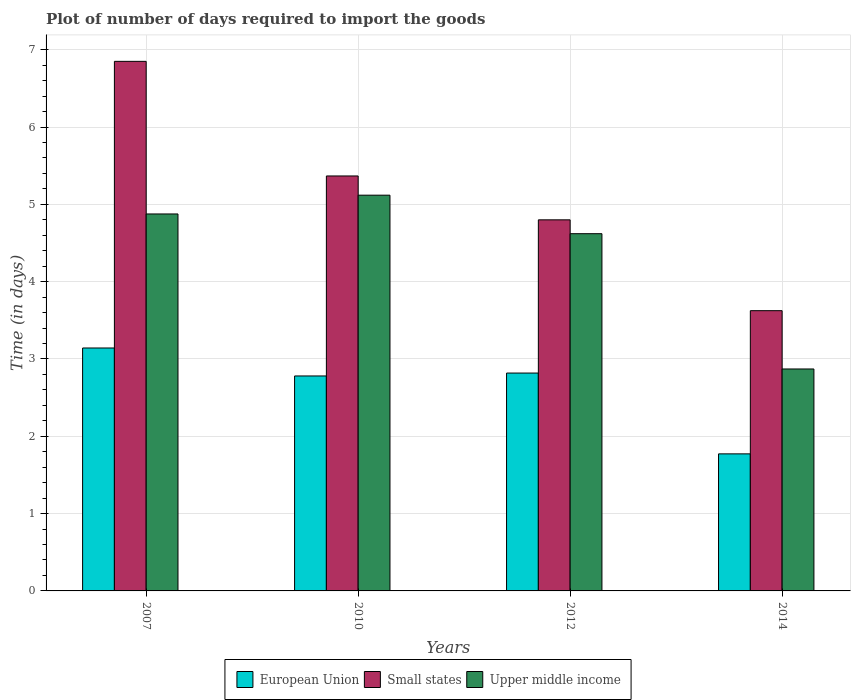How many groups of bars are there?
Make the answer very short. 4. Are the number of bars per tick equal to the number of legend labels?
Provide a short and direct response. Yes. Are the number of bars on each tick of the X-axis equal?
Provide a short and direct response. Yes. How many bars are there on the 1st tick from the left?
Keep it short and to the point. 3. In how many cases, is the number of bars for a given year not equal to the number of legend labels?
Offer a terse response. 0. What is the time required to import goods in Upper middle income in 2014?
Make the answer very short. 2.87. Across all years, what is the maximum time required to import goods in Upper middle income?
Offer a very short reply. 5.12. Across all years, what is the minimum time required to import goods in Small states?
Offer a terse response. 3.62. In which year was the time required to import goods in Small states minimum?
Offer a terse response. 2014. What is the total time required to import goods in Small states in the graph?
Provide a short and direct response. 20.64. What is the difference between the time required to import goods in Small states in 2010 and that in 2014?
Make the answer very short. 1.74. What is the difference between the time required to import goods in Upper middle income in 2007 and the time required to import goods in Small states in 2014?
Offer a terse response. 1.25. What is the average time required to import goods in European Union per year?
Give a very brief answer. 2.63. In the year 2007, what is the difference between the time required to import goods in European Union and time required to import goods in Upper middle income?
Keep it short and to the point. -1.73. In how many years, is the time required to import goods in European Union greater than 4.2 days?
Your answer should be compact. 0. What is the ratio of the time required to import goods in European Union in 2012 to that in 2014?
Ensure brevity in your answer.  1.59. Is the difference between the time required to import goods in European Union in 2007 and 2010 greater than the difference between the time required to import goods in Upper middle income in 2007 and 2010?
Offer a terse response. Yes. What is the difference between the highest and the second highest time required to import goods in European Union?
Give a very brief answer. 0.32. What is the difference between the highest and the lowest time required to import goods in Small states?
Offer a very short reply. 3.22. In how many years, is the time required to import goods in Small states greater than the average time required to import goods in Small states taken over all years?
Give a very brief answer. 2. Is the sum of the time required to import goods in Upper middle income in 2010 and 2014 greater than the maximum time required to import goods in European Union across all years?
Make the answer very short. Yes. What does the 1st bar from the left in 2012 represents?
Offer a very short reply. European Union. What does the 1st bar from the right in 2007 represents?
Give a very brief answer. Upper middle income. Is it the case that in every year, the sum of the time required to import goods in Small states and time required to import goods in Upper middle income is greater than the time required to import goods in European Union?
Give a very brief answer. Yes. How many bars are there?
Your response must be concise. 12. Are all the bars in the graph horizontal?
Ensure brevity in your answer.  No. How many years are there in the graph?
Your response must be concise. 4. What is the title of the graph?
Your response must be concise. Plot of number of days required to import the goods. What is the label or title of the Y-axis?
Keep it short and to the point. Time (in days). What is the Time (in days) of European Union in 2007?
Keep it short and to the point. 3.14. What is the Time (in days) in Small states in 2007?
Your answer should be compact. 6.85. What is the Time (in days) of Upper middle income in 2007?
Offer a very short reply. 4.88. What is the Time (in days) of European Union in 2010?
Your answer should be compact. 2.78. What is the Time (in days) of Small states in 2010?
Ensure brevity in your answer.  5.37. What is the Time (in days) of Upper middle income in 2010?
Offer a terse response. 5.12. What is the Time (in days) of European Union in 2012?
Your answer should be compact. 2.82. What is the Time (in days) in Upper middle income in 2012?
Your response must be concise. 4.62. What is the Time (in days) in European Union in 2014?
Make the answer very short. 1.77. What is the Time (in days) of Small states in 2014?
Your answer should be very brief. 3.62. What is the Time (in days) of Upper middle income in 2014?
Provide a succinct answer. 2.87. Across all years, what is the maximum Time (in days) in European Union?
Your answer should be compact. 3.14. Across all years, what is the maximum Time (in days) in Small states?
Ensure brevity in your answer.  6.85. Across all years, what is the maximum Time (in days) in Upper middle income?
Give a very brief answer. 5.12. Across all years, what is the minimum Time (in days) in European Union?
Your response must be concise. 1.77. Across all years, what is the minimum Time (in days) in Small states?
Provide a short and direct response. 3.62. Across all years, what is the minimum Time (in days) of Upper middle income?
Give a very brief answer. 2.87. What is the total Time (in days) in European Union in the graph?
Offer a very short reply. 10.51. What is the total Time (in days) in Small states in the graph?
Your answer should be very brief. 20.64. What is the total Time (in days) of Upper middle income in the graph?
Your answer should be very brief. 17.49. What is the difference between the Time (in days) of European Union in 2007 and that in 2010?
Ensure brevity in your answer.  0.36. What is the difference between the Time (in days) of Small states in 2007 and that in 2010?
Give a very brief answer. 1.48. What is the difference between the Time (in days) of Upper middle income in 2007 and that in 2010?
Offer a terse response. -0.24. What is the difference between the Time (in days) in European Union in 2007 and that in 2012?
Ensure brevity in your answer.  0.32. What is the difference between the Time (in days) of Small states in 2007 and that in 2012?
Your answer should be compact. 2.05. What is the difference between the Time (in days) of Upper middle income in 2007 and that in 2012?
Offer a terse response. 0.26. What is the difference between the Time (in days) of European Union in 2007 and that in 2014?
Your answer should be very brief. 1.37. What is the difference between the Time (in days) of Small states in 2007 and that in 2014?
Your answer should be compact. 3.23. What is the difference between the Time (in days) of Upper middle income in 2007 and that in 2014?
Offer a terse response. 2. What is the difference between the Time (in days) in European Union in 2010 and that in 2012?
Give a very brief answer. -0.04. What is the difference between the Time (in days) of Small states in 2010 and that in 2012?
Give a very brief answer. 0.57. What is the difference between the Time (in days) of Upper middle income in 2010 and that in 2012?
Keep it short and to the point. 0.5. What is the difference between the Time (in days) in European Union in 2010 and that in 2014?
Your answer should be compact. 1.01. What is the difference between the Time (in days) in Small states in 2010 and that in 2014?
Offer a terse response. 1.74. What is the difference between the Time (in days) of Upper middle income in 2010 and that in 2014?
Keep it short and to the point. 2.25. What is the difference between the Time (in days) of European Union in 2012 and that in 2014?
Make the answer very short. 1.05. What is the difference between the Time (in days) in Small states in 2012 and that in 2014?
Offer a very short reply. 1.18. What is the difference between the Time (in days) of Upper middle income in 2012 and that in 2014?
Your answer should be compact. 1.75. What is the difference between the Time (in days) of European Union in 2007 and the Time (in days) of Small states in 2010?
Your answer should be very brief. -2.23. What is the difference between the Time (in days) of European Union in 2007 and the Time (in days) of Upper middle income in 2010?
Give a very brief answer. -1.98. What is the difference between the Time (in days) of Small states in 2007 and the Time (in days) of Upper middle income in 2010?
Ensure brevity in your answer.  1.73. What is the difference between the Time (in days) of European Union in 2007 and the Time (in days) of Small states in 2012?
Provide a succinct answer. -1.66. What is the difference between the Time (in days) of European Union in 2007 and the Time (in days) of Upper middle income in 2012?
Provide a short and direct response. -1.48. What is the difference between the Time (in days) of Small states in 2007 and the Time (in days) of Upper middle income in 2012?
Your answer should be compact. 2.23. What is the difference between the Time (in days) in European Union in 2007 and the Time (in days) in Small states in 2014?
Your answer should be compact. -0.48. What is the difference between the Time (in days) of European Union in 2007 and the Time (in days) of Upper middle income in 2014?
Provide a succinct answer. 0.27. What is the difference between the Time (in days) in Small states in 2007 and the Time (in days) in Upper middle income in 2014?
Provide a succinct answer. 3.98. What is the difference between the Time (in days) in European Union in 2010 and the Time (in days) in Small states in 2012?
Keep it short and to the point. -2.02. What is the difference between the Time (in days) in European Union in 2010 and the Time (in days) in Upper middle income in 2012?
Your answer should be compact. -1.84. What is the difference between the Time (in days) in Small states in 2010 and the Time (in days) in Upper middle income in 2012?
Provide a short and direct response. 0.75. What is the difference between the Time (in days) in European Union in 2010 and the Time (in days) in Small states in 2014?
Provide a succinct answer. -0.84. What is the difference between the Time (in days) in European Union in 2010 and the Time (in days) in Upper middle income in 2014?
Make the answer very short. -0.09. What is the difference between the Time (in days) in Small states in 2010 and the Time (in days) in Upper middle income in 2014?
Provide a succinct answer. 2.5. What is the difference between the Time (in days) in European Union in 2012 and the Time (in days) in Small states in 2014?
Give a very brief answer. -0.81. What is the difference between the Time (in days) of European Union in 2012 and the Time (in days) of Upper middle income in 2014?
Provide a succinct answer. -0.05. What is the difference between the Time (in days) of Small states in 2012 and the Time (in days) of Upper middle income in 2014?
Offer a terse response. 1.93. What is the average Time (in days) in European Union per year?
Keep it short and to the point. 2.63. What is the average Time (in days) in Small states per year?
Offer a terse response. 5.16. What is the average Time (in days) in Upper middle income per year?
Your response must be concise. 4.37. In the year 2007, what is the difference between the Time (in days) of European Union and Time (in days) of Small states?
Ensure brevity in your answer.  -3.71. In the year 2007, what is the difference between the Time (in days) of European Union and Time (in days) of Upper middle income?
Your response must be concise. -1.73. In the year 2007, what is the difference between the Time (in days) of Small states and Time (in days) of Upper middle income?
Make the answer very short. 1.97. In the year 2010, what is the difference between the Time (in days) in European Union and Time (in days) in Small states?
Offer a very short reply. -2.59. In the year 2010, what is the difference between the Time (in days) of European Union and Time (in days) of Upper middle income?
Offer a very short reply. -2.34. In the year 2010, what is the difference between the Time (in days) of Small states and Time (in days) of Upper middle income?
Provide a succinct answer. 0.25. In the year 2012, what is the difference between the Time (in days) of European Union and Time (in days) of Small states?
Ensure brevity in your answer.  -1.98. In the year 2012, what is the difference between the Time (in days) in European Union and Time (in days) in Upper middle income?
Provide a short and direct response. -1.8. In the year 2012, what is the difference between the Time (in days) in Small states and Time (in days) in Upper middle income?
Keep it short and to the point. 0.18. In the year 2014, what is the difference between the Time (in days) in European Union and Time (in days) in Small states?
Offer a terse response. -1.85. In the year 2014, what is the difference between the Time (in days) of European Union and Time (in days) of Upper middle income?
Your answer should be very brief. -1.1. In the year 2014, what is the difference between the Time (in days) of Small states and Time (in days) of Upper middle income?
Provide a succinct answer. 0.75. What is the ratio of the Time (in days) in European Union in 2007 to that in 2010?
Give a very brief answer. 1.13. What is the ratio of the Time (in days) in Small states in 2007 to that in 2010?
Give a very brief answer. 1.28. What is the ratio of the Time (in days) of Upper middle income in 2007 to that in 2010?
Your response must be concise. 0.95. What is the ratio of the Time (in days) in European Union in 2007 to that in 2012?
Offer a terse response. 1.11. What is the ratio of the Time (in days) in Small states in 2007 to that in 2012?
Give a very brief answer. 1.43. What is the ratio of the Time (in days) of Upper middle income in 2007 to that in 2012?
Provide a short and direct response. 1.06. What is the ratio of the Time (in days) of European Union in 2007 to that in 2014?
Your answer should be compact. 1.77. What is the ratio of the Time (in days) in Small states in 2007 to that in 2014?
Your response must be concise. 1.89. What is the ratio of the Time (in days) in Upper middle income in 2007 to that in 2014?
Make the answer very short. 1.7. What is the ratio of the Time (in days) in European Union in 2010 to that in 2012?
Your answer should be compact. 0.99. What is the ratio of the Time (in days) in Small states in 2010 to that in 2012?
Provide a succinct answer. 1.12. What is the ratio of the Time (in days) of Upper middle income in 2010 to that in 2012?
Your answer should be very brief. 1.11. What is the ratio of the Time (in days) of European Union in 2010 to that in 2014?
Your response must be concise. 1.57. What is the ratio of the Time (in days) of Small states in 2010 to that in 2014?
Offer a terse response. 1.48. What is the ratio of the Time (in days) of Upper middle income in 2010 to that in 2014?
Your response must be concise. 1.78. What is the ratio of the Time (in days) in European Union in 2012 to that in 2014?
Your answer should be very brief. 1.59. What is the ratio of the Time (in days) in Small states in 2012 to that in 2014?
Your response must be concise. 1.32. What is the ratio of the Time (in days) in Upper middle income in 2012 to that in 2014?
Keep it short and to the point. 1.61. What is the difference between the highest and the second highest Time (in days) of European Union?
Offer a terse response. 0.32. What is the difference between the highest and the second highest Time (in days) in Small states?
Keep it short and to the point. 1.48. What is the difference between the highest and the second highest Time (in days) of Upper middle income?
Offer a terse response. 0.24. What is the difference between the highest and the lowest Time (in days) of European Union?
Offer a terse response. 1.37. What is the difference between the highest and the lowest Time (in days) in Small states?
Make the answer very short. 3.23. What is the difference between the highest and the lowest Time (in days) of Upper middle income?
Give a very brief answer. 2.25. 